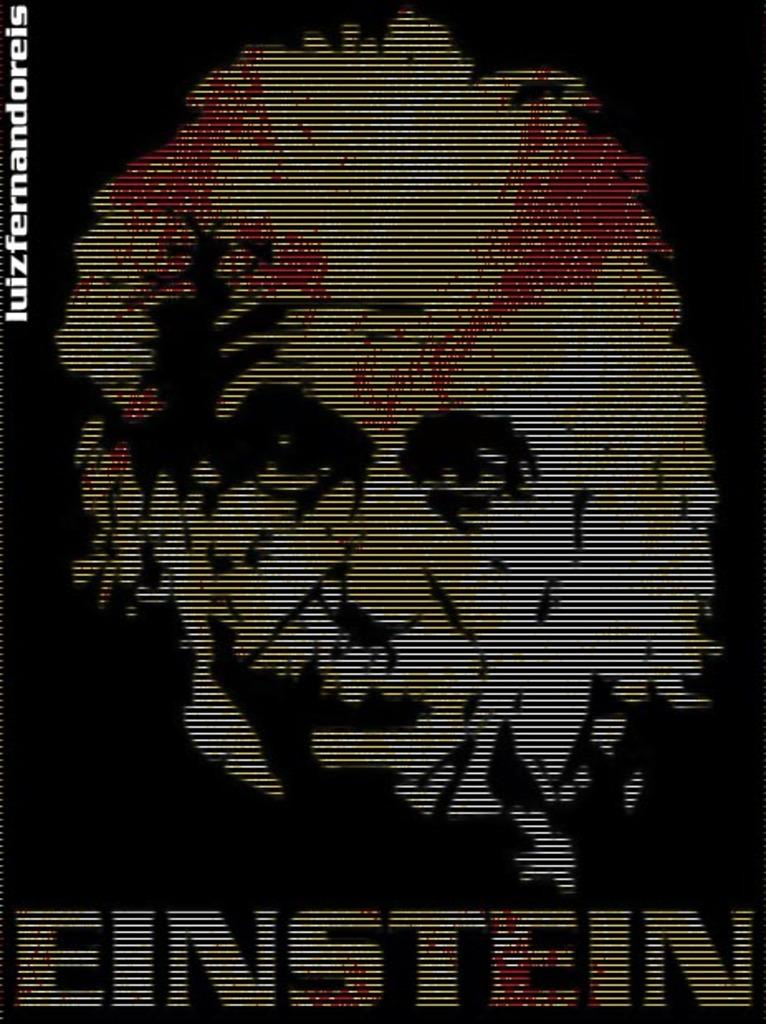<image>
Create a compact narrative representing the image presented. A black and gold poster of Albert Einstein. 